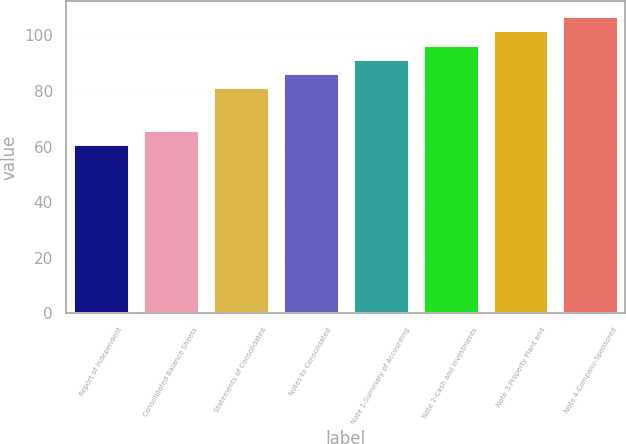Convert chart to OTSL. <chart><loc_0><loc_0><loc_500><loc_500><bar_chart><fcel>Report of Independent<fcel>Consolidated Balance Sheets<fcel>Statements of Consolidated<fcel>Notes to Consolidated<fcel>Note 1-Summary of Accounting<fcel>Note 2-Cash and Investments<fcel>Note 3-Property Plant and<fcel>Note 4-Company-Sponsored<nl><fcel>61<fcel>66.1<fcel>81.4<fcel>86.5<fcel>91.6<fcel>96.7<fcel>101.8<fcel>106.9<nl></chart> 